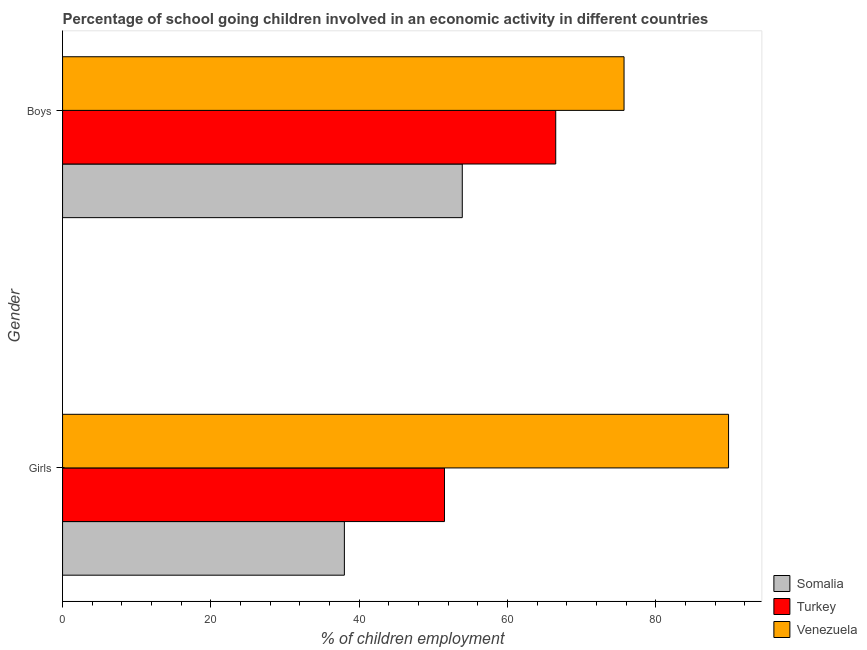How many groups of bars are there?
Your answer should be very brief. 2. How many bars are there on the 2nd tick from the top?
Provide a succinct answer. 3. How many bars are there on the 2nd tick from the bottom?
Ensure brevity in your answer.  3. What is the label of the 1st group of bars from the top?
Make the answer very short. Boys. What is the percentage of school going boys in Venezuela?
Give a very brief answer. 75.71. Across all countries, what is the maximum percentage of school going boys?
Give a very brief answer. 75.71. Across all countries, what is the minimum percentage of school going girls?
Your answer should be compact. 38. In which country was the percentage of school going girls maximum?
Make the answer very short. Venezuela. In which country was the percentage of school going girls minimum?
Ensure brevity in your answer.  Somalia. What is the total percentage of school going boys in the graph?
Provide a succinct answer. 196.11. What is the difference between the percentage of school going boys in Turkey and that in Somalia?
Your answer should be very brief. 12.6. What is the difference between the percentage of school going girls in Somalia and the percentage of school going boys in Turkey?
Keep it short and to the point. -28.5. What is the average percentage of school going boys per country?
Your answer should be very brief. 65.37. What is the difference between the percentage of school going girls and percentage of school going boys in Somalia?
Your answer should be compact. -15.9. In how many countries, is the percentage of school going girls greater than 12 %?
Offer a very short reply. 3. What is the ratio of the percentage of school going girls in Turkey to that in Somalia?
Give a very brief answer. 1.36. Is the percentage of school going boys in Somalia less than that in Venezuela?
Keep it short and to the point. Yes. What does the 2nd bar from the top in Boys represents?
Provide a short and direct response. Turkey. What does the 2nd bar from the bottom in Girls represents?
Your answer should be compact. Turkey. Are all the bars in the graph horizontal?
Provide a short and direct response. Yes. How many countries are there in the graph?
Make the answer very short. 3. What is the difference between two consecutive major ticks on the X-axis?
Provide a short and direct response. 20. Does the graph contain grids?
Give a very brief answer. No. Where does the legend appear in the graph?
Provide a succinct answer. Bottom right. How many legend labels are there?
Your answer should be compact. 3. How are the legend labels stacked?
Offer a very short reply. Vertical. What is the title of the graph?
Provide a short and direct response. Percentage of school going children involved in an economic activity in different countries. Does "Brunei Darussalam" appear as one of the legend labels in the graph?
Give a very brief answer. No. What is the label or title of the X-axis?
Your response must be concise. % of children employment. What is the label or title of the Y-axis?
Make the answer very short. Gender. What is the % of children employment in Somalia in Girls?
Provide a short and direct response. 38. What is the % of children employment of Turkey in Girls?
Offer a terse response. 51.5. What is the % of children employment of Venezuela in Girls?
Provide a short and direct response. 89.81. What is the % of children employment of Somalia in Boys?
Offer a very short reply. 53.9. What is the % of children employment of Turkey in Boys?
Ensure brevity in your answer.  66.5. What is the % of children employment of Venezuela in Boys?
Your answer should be very brief. 75.71. Across all Gender, what is the maximum % of children employment in Somalia?
Keep it short and to the point. 53.9. Across all Gender, what is the maximum % of children employment of Turkey?
Offer a very short reply. 66.5. Across all Gender, what is the maximum % of children employment of Venezuela?
Make the answer very short. 89.81. Across all Gender, what is the minimum % of children employment in Turkey?
Offer a very short reply. 51.5. Across all Gender, what is the minimum % of children employment in Venezuela?
Make the answer very short. 75.71. What is the total % of children employment in Somalia in the graph?
Ensure brevity in your answer.  91.9. What is the total % of children employment of Turkey in the graph?
Your answer should be very brief. 118. What is the total % of children employment in Venezuela in the graph?
Provide a short and direct response. 165.52. What is the difference between the % of children employment in Somalia in Girls and that in Boys?
Provide a short and direct response. -15.9. What is the difference between the % of children employment of Turkey in Girls and that in Boys?
Offer a very short reply. -15. What is the difference between the % of children employment in Venezuela in Girls and that in Boys?
Keep it short and to the point. 14.09. What is the difference between the % of children employment of Somalia in Girls and the % of children employment of Turkey in Boys?
Offer a very short reply. -28.5. What is the difference between the % of children employment in Somalia in Girls and the % of children employment in Venezuela in Boys?
Your response must be concise. -37.71. What is the difference between the % of children employment of Turkey in Girls and the % of children employment of Venezuela in Boys?
Provide a succinct answer. -24.21. What is the average % of children employment in Somalia per Gender?
Provide a succinct answer. 45.95. What is the average % of children employment in Venezuela per Gender?
Keep it short and to the point. 82.76. What is the difference between the % of children employment in Somalia and % of children employment in Turkey in Girls?
Offer a very short reply. -13.5. What is the difference between the % of children employment in Somalia and % of children employment in Venezuela in Girls?
Ensure brevity in your answer.  -51.81. What is the difference between the % of children employment of Turkey and % of children employment of Venezuela in Girls?
Make the answer very short. -38.31. What is the difference between the % of children employment in Somalia and % of children employment in Turkey in Boys?
Ensure brevity in your answer.  -12.6. What is the difference between the % of children employment in Somalia and % of children employment in Venezuela in Boys?
Keep it short and to the point. -21.81. What is the difference between the % of children employment of Turkey and % of children employment of Venezuela in Boys?
Your response must be concise. -9.21. What is the ratio of the % of children employment of Somalia in Girls to that in Boys?
Offer a very short reply. 0.7. What is the ratio of the % of children employment of Turkey in Girls to that in Boys?
Keep it short and to the point. 0.77. What is the ratio of the % of children employment of Venezuela in Girls to that in Boys?
Your answer should be compact. 1.19. What is the difference between the highest and the second highest % of children employment of Somalia?
Your answer should be very brief. 15.9. What is the difference between the highest and the second highest % of children employment in Venezuela?
Your answer should be very brief. 14.09. What is the difference between the highest and the lowest % of children employment in Somalia?
Your answer should be compact. 15.9. What is the difference between the highest and the lowest % of children employment in Venezuela?
Offer a terse response. 14.09. 